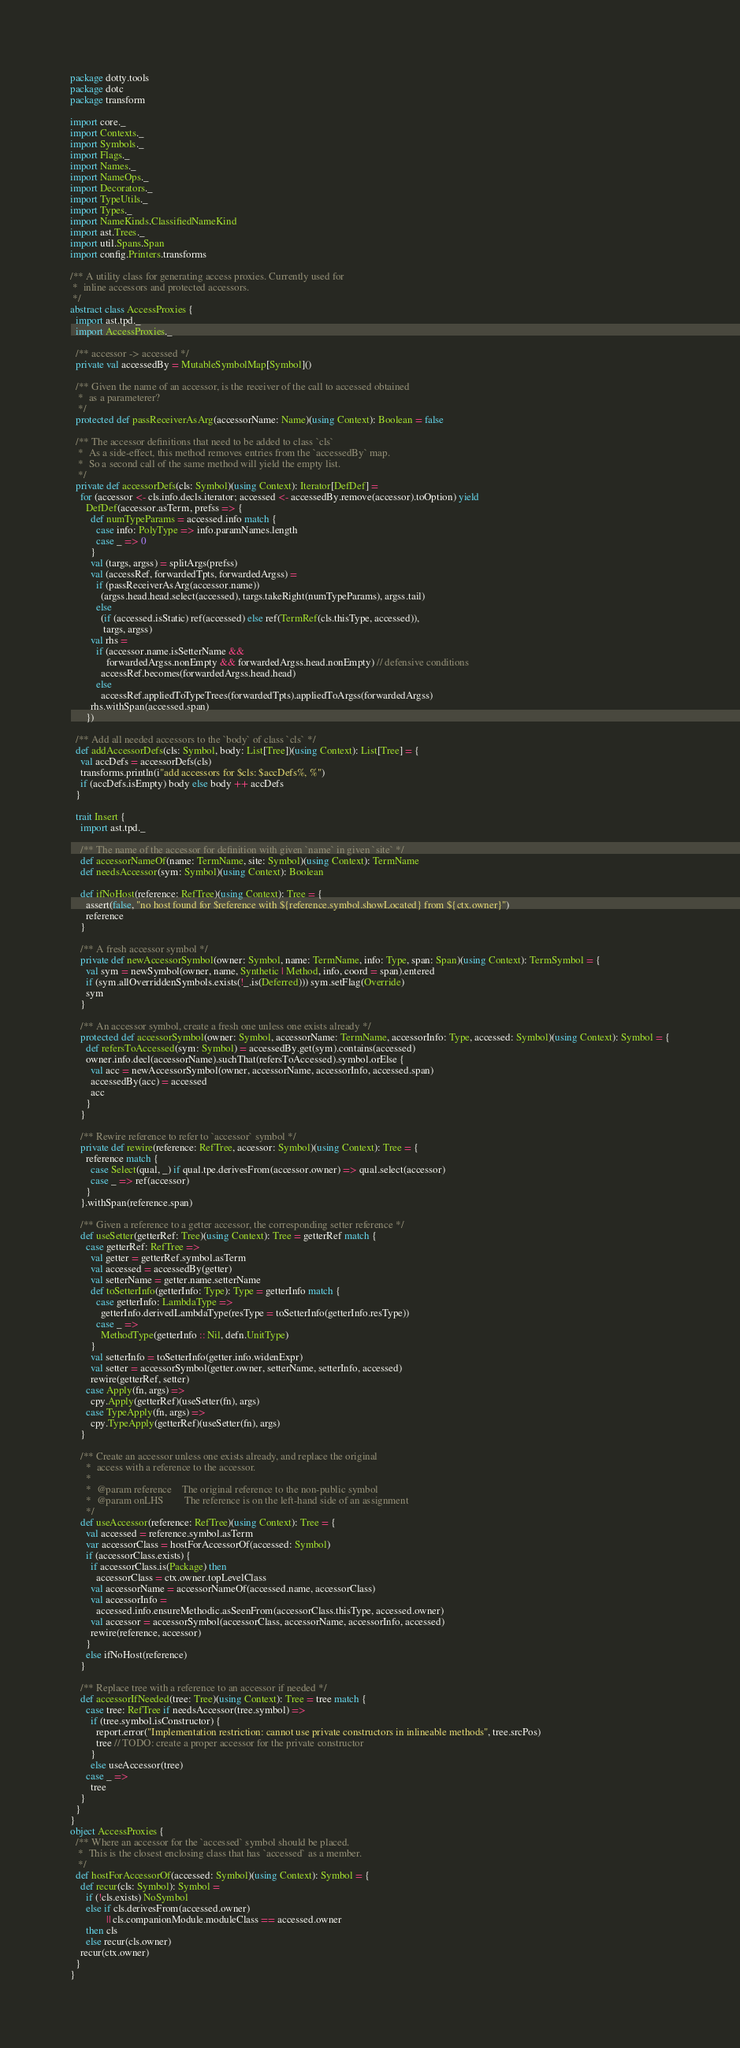<code> <loc_0><loc_0><loc_500><loc_500><_Scala_>package dotty.tools
package dotc
package transform

import core._
import Contexts._
import Symbols._
import Flags._
import Names._
import NameOps._
import Decorators._
import TypeUtils._
import Types._
import NameKinds.ClassifiedNameKind
import ast.Trees._
import util.Spans.Span
import config.Printers.transforms

/** A utility class for generating access proxies. Currently used for
 *  inline accessors and protected accessors.
 */
abstract class AccessProxies {
  import ast.tpd._
  import AccessProxies._

  /** accessor -> accessed */
  private val accessedBy = MutableSymbolMap[Symbol]()

  /** Given the name of an accessor, is the receiver of the call to accessed obtained
   *  as a parameterer?
   */
  protected def passReceiverAsArg(accessorName: Name)(using Context): Boolean = false

  /** The accessor definitions that need to be added to class `cls`
   *  As a side-effect, this method removes entries from the `accessedBy` map.
   *  So a second call of the same method will yield the empty list.
   */
  private def accessorDefs(cls: Symbol)(using Context): Iterator[DefDef] =
    for (accessor <- cls.info.decls.iterator; accessed <- accessedBy.remove(accessor).toOption) yield
      DefDef(accessor.asTerm, prefss => {
        def numTypeParams = accessed.info match {
          case info: PolyType => info.paramNames.length
          case _ => 0
        }
        val (targs, argss) = splitArgs(prefss)
        val (accessRef, forwardedTpts, forwardedArgss) =
          if (passReceiverAsArg(accessor.name))
            (argss.head.head.select(accessed), targs.takeRight(numTypeParams), argss.tail)
          else
            (if (accessed.isStatic) ref(accessed) else ref(TermRef(cls.thisType, accessed)),
             targs, argss)
        val rhs =
          if (accessor.name.isSetterName &&
              forwardedArgss.nonEmpty && forwardedArgss.head.nonEmpty) // defensive conditions
            accessRef.becomes(forwardedArgss.head.head)
          else
            accessRef.appliedToTypeTrees(forwardedTpts).appliedToArgss(forwardedArgss)
        rhs.withSpan(accessed.span)
      })

  /** Add all needed accessors to the `body` of class `cls` */
  def addAccessorDefs(cls: Symbol, body: List[Tree])(using Context): List[Tree] = {
    val accDefs = accessorDefs(cls)
    transforms.println(i"add accessors for $cls: $accDefs%, %")
    if (accDefs.isEmpty) body else body ++ accDefs
  }

  trait Insert {
    import ast.tpd._

    /** The name of the accessor for definition with given `name` in given `site` */
    def accessorNameOf(name: TermName, site: Symbol)(using Context): TermName
    def needsAccessor(sym: Symbol)(using Context): Boolean

    def ifNoHost(reference: RefTree)(using Context): Tree = {
      assert(false, "no host found for $reference with ${reference.symbol.showLocated} from ${ctx.owner}")
      reference
    }

    /** A fresh accessor symbol */
    private def newAccessorSymbol(owner: Symbol, name: TermName, info: Type, span: Span)(using Context): TermSymbol = {
      val sym = newSymbol(owner, name, Synthetic | Method, info, coord = span).entered
      if (sym.allOverriddenSymbols.exists(!_.is(Deferred))) sym.setFlag(Override)
      sym
    }

    /** An accessor symbol, create a fresh one unless one exists already */
    protected def accessorSymbol(owner: Symbol, accessorName: TermName, accessorInfo: Type, accessed: Symbol)(using Context): Symbol = {
      def refersToAccessed(sym: Symbol) = accessedBy.get(sym).contains(accessed)
      owner.info.decl(accessorName).suchThat(refersToAccessed).symbol.orElse {
        val acc = newAccessorSymbol(owner, accessorName, accessorInfo, accessed.span)
        accessedBy(acc) = accessed
        acc
      }
    }

    /** Rewire reference to refer to `accessor` symbol */
    private def rewire(reference: RefTree, accessor: Symbol)(using Context): Tree = {
      reference match {
        case Select(qual, _) if qual.tpe.derivesFrom(accessor.owner) => qual.select(accessor)
        case _ => ref(accessor)
      }
    }.withSpan(reference.span)

    /** Given a reference to a getter accessor, the corresponding setter reference */
    def useSetter(getterRef: Tree)(using Context): Tree = getterRef match {
      case getterRef: RefTree =>
        val getter = getterRef.symbol.asTerm
        val accessed = accessedBy(getter)
        val setterName = getter.name.setterName
        def toSetterInfo(getterInfo: Type): Type = getterInfo match {
          case getterInfo: LambdaType =>
            getterInfo.derivedLambdaType(resType = toSetterInfo(getterInfo.resType))
          case _ =>
            MethodType(getterInfo :: Nil, defn.UnitType)
        }
        val setterInfo = toSetterInfo(getter.info.widenExpr)
        val setter = accessorSymbol(getter.owner, setterName, setterInfo, accessed)
        rewire(getterRef, setter)
      case Apply(fn, args) =>
        cpy.Apply(getterRef)(useSetter(fn), args)
      case TypeApply(fn, args) =>
        cpy.TypeApply(getterRef)(useSetter(fn), args)
    }

    /** Create an accessor unless one exists already, and replace the original
      *  access with a reference to the accessor.
      *
      *  @param reference    The original reference to the non-public symbol
      *  @param onLHS        The reference is on the left-hand side of an assignment
      */
    def useAccessor(reference: RefTree)(using Context): Tree = {
      val accessed = reference.symbol.asTerm
      var accessorClass = hostForAccessorOf(accessed: Symbol)
      if (accessorClass.exists) {
        if accessorClass.is(Package) then
          accessorClass = ctx.owner.topLevelClass
        val accessorName = accessorNameOf(accessed.name, accessorClass)
        val accessorInfo =
          accessed.info.ensureMethodic.asSeenFrom(accessorClass.thisType, accessed.owner)
        val accessor = accessorSymbol(accessorClass, accessorName, accessorInfo, accessed)
        rewire(reference, accessor)
      }
      else ifNoHost(reference)
    }

    /** Replace tree with a reference to an accessor if needed */
    def accessorIfNeeded(tree: Tree)(using Context): Tree = tree match {
      case tree: RefTree if needsAccessor(tree.symbol) =>
        if (tree.symbol.isConstructor) {
          report.error("Implementation restriction: cannot use private constructors in inlineable methods", tree.srcPos)
          tree // TODO: create a proper accessor for the private constructor
        }
        else useAccessor(tree)
      case _ =>
        tree
    }
  }
}
object AccessProxies {
  /** Where an accessor for the `accessed` symbol should be placed.
   *  This is the closest enclosing class that has `accessed` as a member.
   */
  def hostForAccessorOf(accessed: Symbol)(using Context): Symbol = {
    def recur(cls: Symbol): Symbol =
      if (!cls.exists) NoSymbol
      else if cls.derivesFrom(accessed.owner)
              || cls.companionModule.moduleClass == accessed.owner
      then cls
      else recur(cls.owner)
    recur(ctx.owner)
  }
}
</code> 